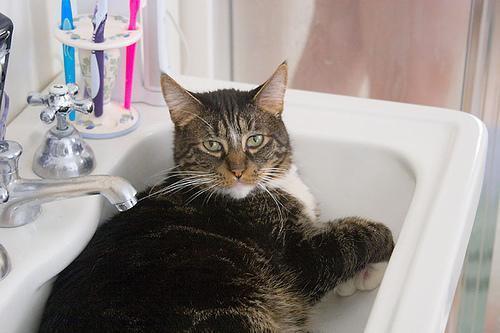How many cats are there?
Give a very brief answer. 1. How many toothbrushes are there?
Give a very brief answer. 3. How many toothbrushes are visible?
Give a very brief answer. 3. How many cats can you see?
Give a very brief answer. 1. 